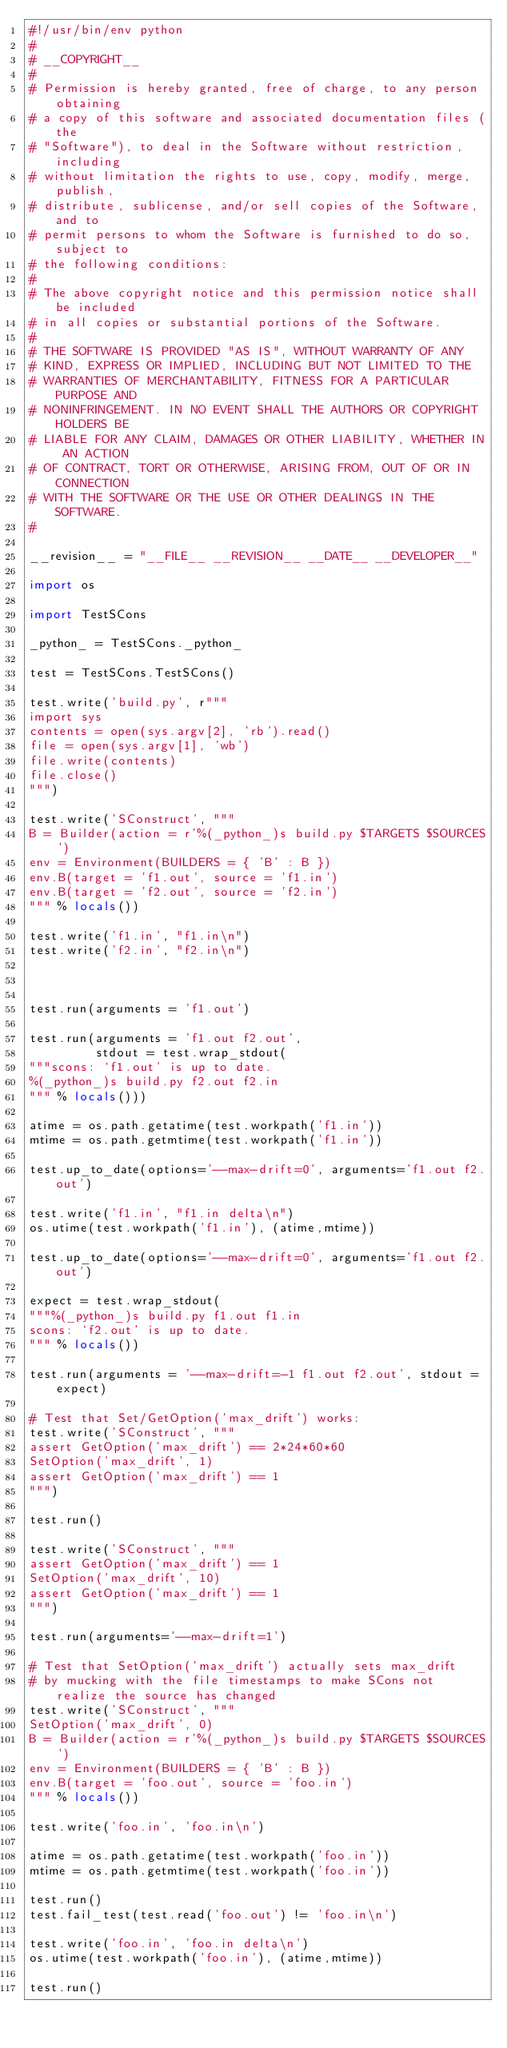Convert code to text. <code><loc_0><loc_0><loc_500><loc_500><_Python_>#!/usr/bin/env python
#
# __COPYRIGHT__
#
# Permission is hereby granted, free of charge, to any person obtaining
# a copy of this software and associated documentation files (the
# "Software"), to deal in the Software without restriction, including
# without limitation the rights to use, copy, modify, merge, publish,
# distribute, sublicense, and/or sell copies of the Software, and to
# permit persons to whom the Software is furnished to do so, subject to
# the following conditions:
#
# The above copyright notice and this permission notice shall be included
# in all copies or substantial portions of the Software.
#
# THE SOFTWARE IS PROVIDED "AS IS", WITHOUT WARRANTY OF ANY
# KIND, EXPRESS OR IMPLIED, INCLUDING BUT NOT LIMITED TO THE
# WARRANTIES OF MERCHANTABILITY, FITNESS FOR A PARTICULAR PURPOSE AND
# NONINFRINGEMENT. IN NO EVENT SHALL THE AUTHORS OR COPYRIGHT HOLDERS BE
# LIABLE FOR ANY CLAIM, DAMAGES OR OTHER LIABILITY, WHETHER IN AN ACTION
# OF CONTRACT, TORT OR OTHERWISE, ARISING FROM, OUT OF OR IN CONNECTION
# WITH THE SOFTWARE OR THE USE OR OTHER DEALINGS IN THE SOFTWARE.
#

__revision__ = "__FILE__ __REVISION__ __DATE__ __DEVELOPER__"

import os

import TestSCons

_python_ = TestSCons._python_

test = TestSCons.TestSCons()

test.write('build.py', r"""
import sys
contents = open(sys.argv[2], 'rb').read()
file = open(sys.argv[1], 'wb')
file.write(contents)
file.close()
""")

test.write('SConstruct', """
B = Builder(action = r'%(_python_)s build.py $TARGETS $SOURCES')
env = Environment(BUILDERS = { 'B' : B })
env.B(target = 'f1.out', source = 'f1.in')
env.B(target = 'f2.out', source = 'f2.in')
""" % locals())

test.write('f1.in', "f1.in\n")
test.write('f2.in', "f2.in\n")



test.run(arguments = 'f1.out')

test.run(arguments = 'f1.out f2.out',
         stdout = test.wrap_stdout(
"""scons: `f1.out' is up to date.
%(_python_)s build.py f2.out f2.in
""" % locals()))

atime = os.path.getatime(test.workpath('f1.in'))
mtime = os.path.getmtime(test.workpath('f1.in'))

test.up_to_date(options='--max-drift=0', arguments='f1.out f2.out')

test.write('f1.in', "f1.in delta\n")
os.utime(test.workpath('f1.in'), (atime,mtime))

test.up_to_date(options='--max-drift=0', arguments='f1.out f2.out')

expect = test.wrap_stdout(
"""%(_python_)s build.py f1.out f1.in
scons: `f2.out' is up to date.
""" % locals())

test.run(arguments = '--max-drift=-1 f1.out f2.out', stdout = expect)

# Test that Set/GetOption('max_drift') works:
test.write('SConstruct', """
assert GetOption('max_drift') == 2*24*60*60
SetOption('max_drift', 1)
assert GetOption('max_drift') == 1
""")

test.run()

test.write('SConstruct', """
assert GetOption('max_drift') == 1
SetOption('max_drift', 10)
assert GetOption('max_drift') == 1
""")

test.run(arguments='--max-drift=1')

# Test that SetOption('max_drift') actually sets max_drift
# by mucking with the file timestamps to make SCons not realize the source has changed
test.write('SConstruct', """
SetOption('max_drift', 0)
B = Builder(action = r'%(_python_)s build.py $TARGETS $SOURCES')
env = Environment(BUILDERS = { 'B' : B })
env.B(target = 'foo.out', source = 'foo.in')
""" % locals())

test.write('foo.in', 'foo.in\n')

atime = os.path.getatime(test.workpath('foo.in'))
mtime = os.path.getmtime(test.workpath('foo.in'))

test.run()
test.fail_test(test.read('foo.out') != 'foo.in\n')

test.write('foo.in', 'foo.in delta\n')
os.utime(test.workpath('foo.in'), (atime,mtime))

test.run()
</code> 